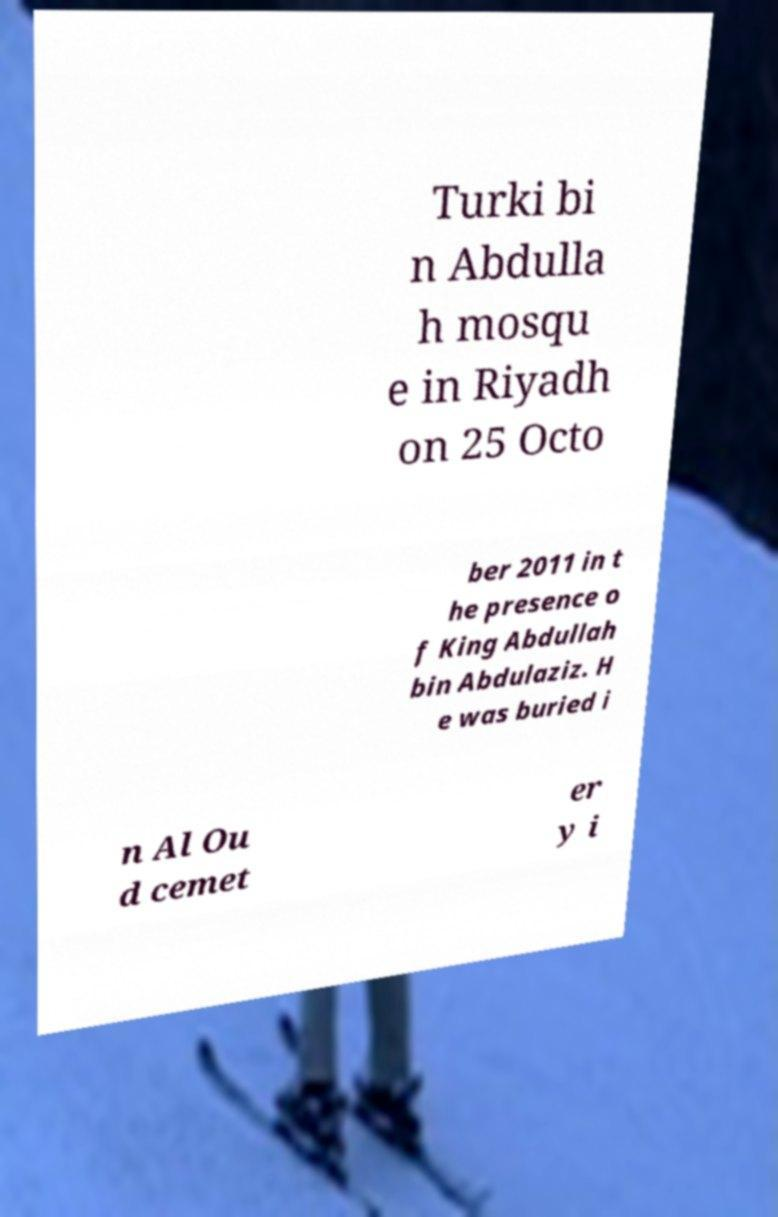For documentation purposes, I need the text within this image transcribed. Could you provide that? Turki bi n Abdulla h mosqu e in Riyadh on 25 Octo ber 2011 in t he presence o f King Abdullah bin Abdulaziz. H e was buried i n Al Ou d cemet er y i 